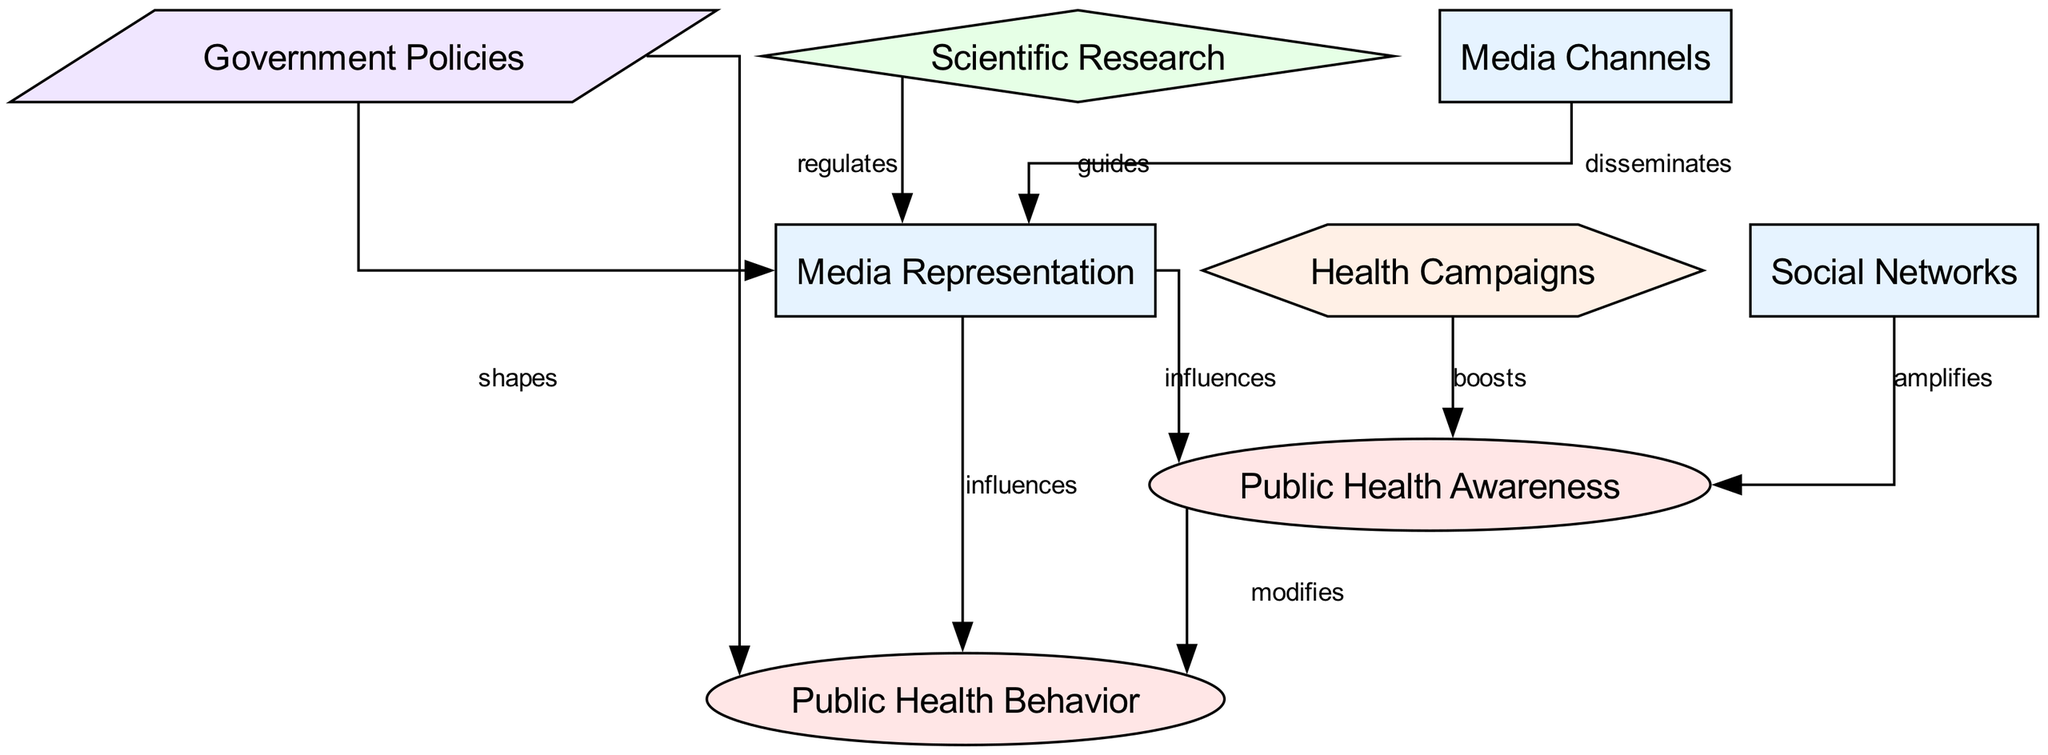What are the two outcomes in the diagram? The diagram identifies two outcomes: "Public Health Awareness" and "Public Health Behavior." These outcomes are represented as ellipse nodes in the diagram.
Answer: Public Health Awareness, Public Health Behavior How many nodes are present in the diagram? By counting all the unique elements labeled as nodes in the diagram, we find there are eight distinct nodes in total.
Answer: 8 What type is the node "scientific_research"? The node "scientific_research" is categorized as evidence, which is indicated by its diamond shape and the context in which it operates within the diagram.
Answer: evidence Which factor directly amplifies public health awareness? The "Social Networks" node is pointed to as it directly amplifies public health awareness according to the edge label from social networks to public health awareness.
Answer: Social Networks What influence do health campaigns have on public health awareness? Health campaigns are shown to boost public health awareness in the diagram, as indicated by the directed edge linking health campaigns to public health awareness with the label "boosts."
Answer: boosts How does government policy influence public health behavior? Government policies are represented as shaping public health behavior, which is indicated by the directed edge from government policies to public health behavior, labeled "shapes."
Answer: shapes What type of intervention is represented in the diagram? The diagram includes "health_campaigns" as an intervention, represented by a hexagonal node and contributing positively to public health awareness.
Answer: intervention Which node disseminates media representation? The node "media_channels" is identified as disseminating media representation, as shown by the edge connecting media channels to media representation with the label "disseminates."
Answer: Media Channels 